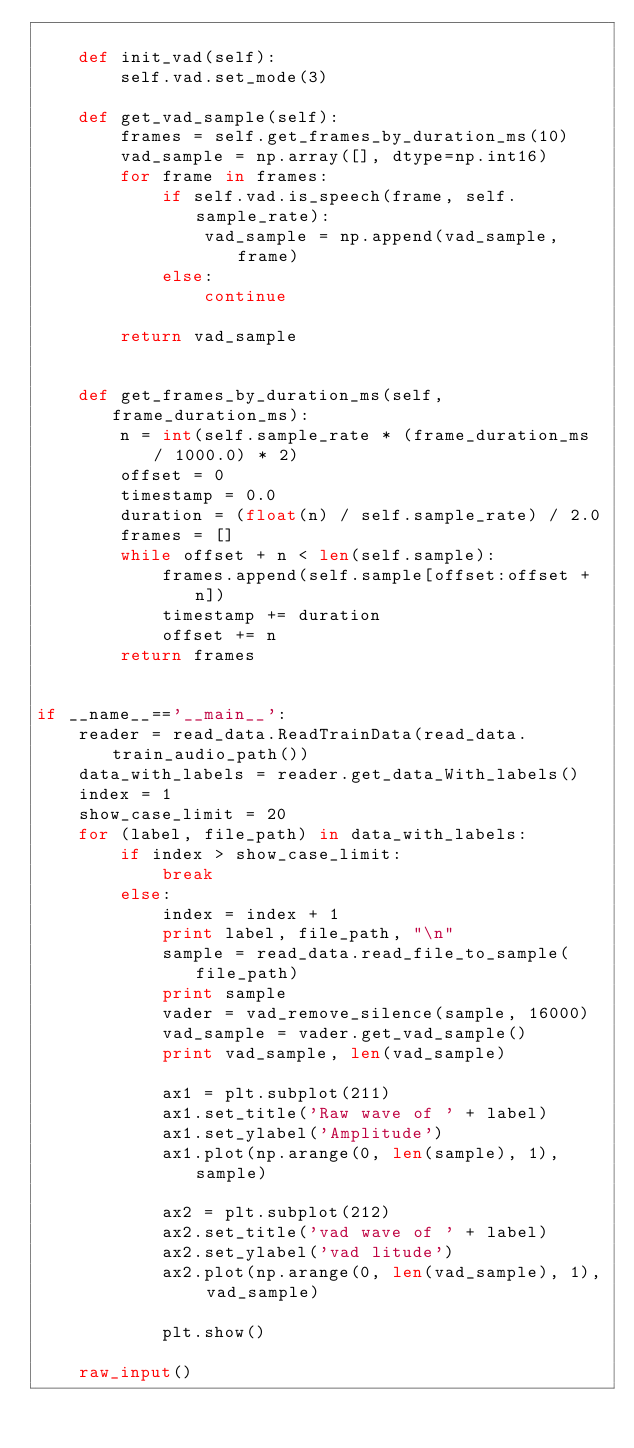<code> <loc_0><loc_0><loc_500><loc_500><_Python_>
    def init_vad(self):
        self.vad.set_mode(3)

    def get_vad_sample(self):
        frames = self.get_frames_by_duration_ms(10)
        vad_sample = np.array([], dtype=np.int16)
        for frame in frames:
            if self.vad.is_speech(frame, self.sample_rate):
                vad_sample = np.append(vad_sample, frame)
            else:
                continue

        return vad_sample


    def get_frames_by_duration_ms(self, frame_duration_ms):
        n = int(self.sample_rate * (frame_duration_ms / 1000.0) * 2)
        offset = 0
        timestamp = 0.0
        duration = (float(n) / self.sample_rate) / 2.0
        frames = []
        while offset + n < len(self.sample):
            frames.append(self.sample[offset:offset + n])
            timestamp += duration
            offset += n
        return frames


if __name__=='__main__':
    reader = read_data.ReadTrainData(read_data.train_audio_path())
    data_with_labels = reader.get_data_With_labels()
    index = 1
    show_case_limit = 20
    for (label, file_path) in data_with_labels:
        if index > show_case_limit:
            break
        else:
            index = index + 1
            print label, file_path, "\n"
            sample = read_data.read_file_to_sample(file_path)
            print sample
            vader = vad_remove_silence(sample, 16000)
            vad_sample = vader.get_vad_sample()
            print vad_sample, len(vad_sample)

            ax1 = plt.subplot(211)
            ax1.set_title('Raw wave of ' + label)
            ax1.set_ylabel('Amplitude')
            ax1.plot(np.arange(0, len(sample), 1), sample)

            ax2 = plt.subplot(212)
            ax2.set_title('vad wave of ' + label)
            ax2.set_ylabel('vad litude')
            ax2.plot(np.arange(0, len(vad_sample), 1), vad_sample)

            plt.show()

    raw_input()



</code> 